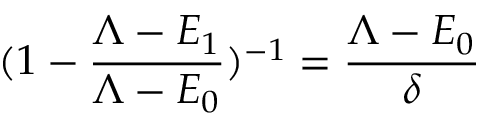Convert formula to latex. <formula><loc_0><loc_0><loc_500><loc_500>( 1 - \frac { \Lambda - E _ { 1 } } { \Lambda - E _ { 0 } } ) ^ { - 1 } = \frac { \Lambda - E _ { 0 } } { \delta }</formula> 